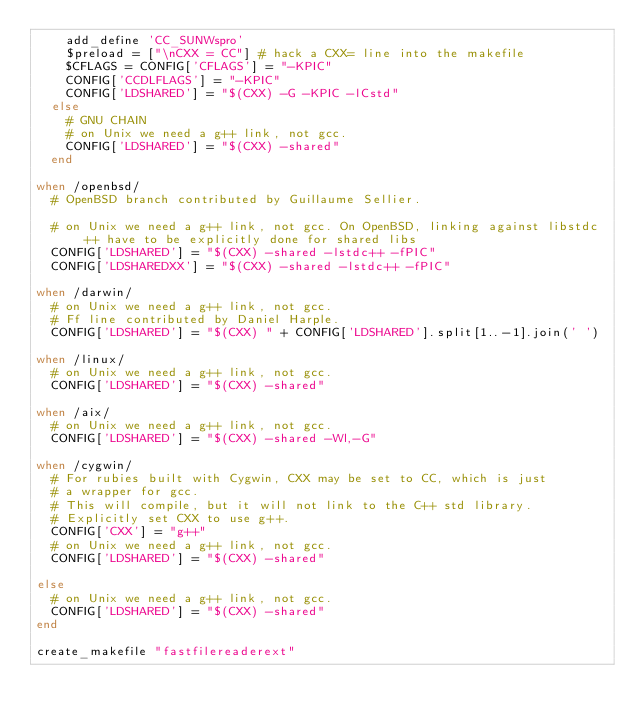<code> <loc_0><loc_0><loc_500><loc_500><_Ruby_>    add_define 'CC_SUNWspro'
    $preload = ["\nCXX = CC"] # hack a CXX= line into the makefile
    $CFLAGS = CONFIG['CFLAGS'] = "-KPIC"
    CONFIG['CCDLFLAGS'] = "-KPIC"
    CONFIG['LDSHARED'] = "$(CXX) -G -KPIC -lCstd"
  else
    # GNU CHAIN
    # on Unix we need a g++ link, not gcc.
    CONFIG['LDSHARED'] = "$(CXX) -shared"
  end

when /openbsd/
  # OpenBSD branch contributed by Guillaume Sellier.

  # on Unix we need a g++ link, not gcc. On OpenBSD, linking against libstdc++ have to be explicitly done for shared libs
  CONFIG['LDSHARED'] = "$(CXX) -shared -lstdc++ -fPIC"
  CONFIG['LDSHAREDXX'] = "$(CXX) -shared -lstdc++ -fPIC"

when /darwin/
  # on Unix we need a g++ link, not gcc.
  # Ff line contributed by Daniel Harple.
  CONFIG['LDSHARED'] = "$(CXX) " + CONFIG['LDSHARED'].split[1..-1].join(' ')

when /linux/
  # on Unix we need a g++ link, not gcc.
  CONFIG['LDSHARED'] = "$(CXX) -shared"

when /aix/
  # on Unix we need a g++ link, not gcc.
  CONFIG['LDSHARED'] = "$(CXX) -shared -Wl,-G"

when /cygwin/
  # For rubies built with Cygwin, CXX may be set to CC, which is just
  # a wrapper for gcc.
  # This will compile, but it will not link to the C++ std library.
  # Explicitly set CXX to use g++.
  CONFIG['CXX'] = "g++"
  # on Unix we need a g++ link, not gcc.
  CONFIG['LDSHARED'] = "$(CXX) -shared"

else
  # on Unix we need a g++ link, not gcc.
  CONFIG['LDSHARED'] = "$(CXX) -shared"
end

create_makefile "fastfilereaderext"
</code> 